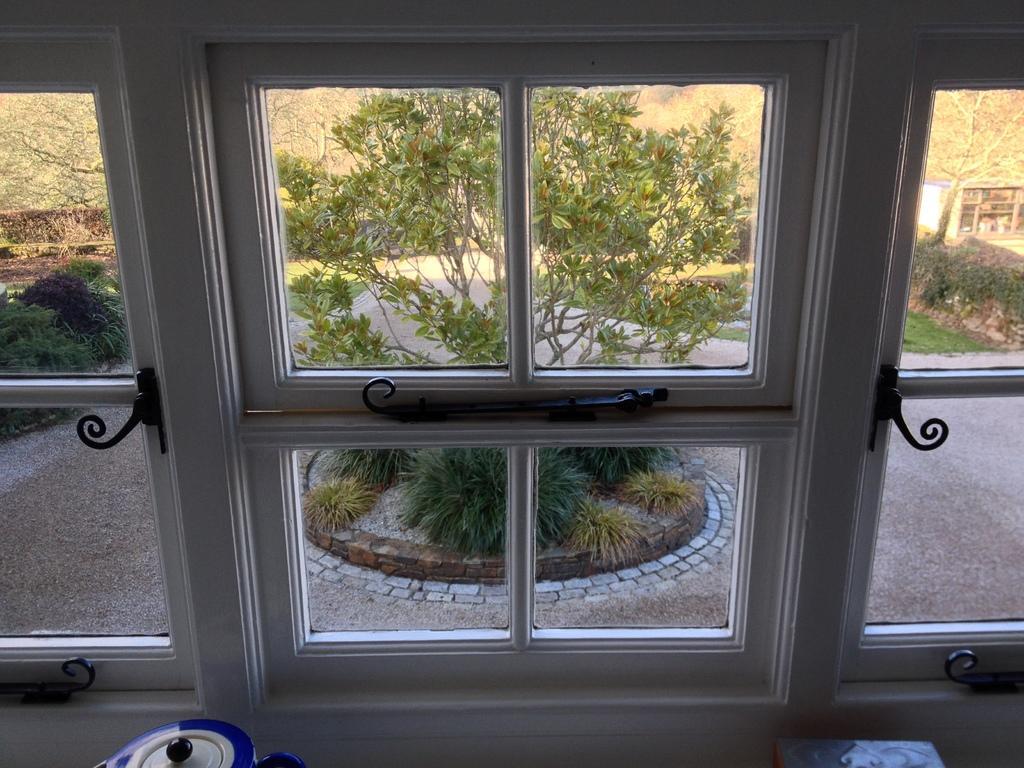Please provide a concise description of this image. There is a glass window which is white in color and there are trees in the background. 